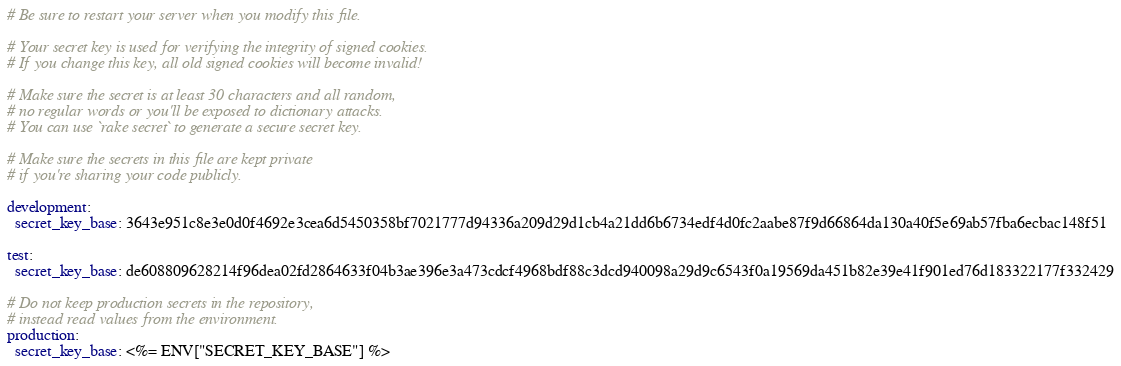Convert code to text. <code><loc_0><loc_0><loc_500><loc_500><_YAML_># Be sure to restart your server when you modify this file.

# Your secret key is used for verifying the integrity of signed cookies.
# If you change this key, all old signed cookies will become invalid!

# Make sure the secret is at least 30 characters and all random,
# no regular words or you'll be exposed to dictionary attacks.
# You can use `rake secret` to generate a secure secret key.

# Make sure the secrets in this file are kept private
# if you're sharing your code publicly.

development:
  secret_key_base: 3643e951c8e3e0d0f4692e3cea6d5450358bf7021777d94336a209d29d1cb4a21dd6b6734edf4d0fc2aabe87f9d66864da130a40f5e69ab57fba6ecbac148f51

test:
  secret_key_base: de608809628214f96dea02fd2864633f04b3ae396e3a473cdcf4968bdf88c3dcd940098a29d9c6543f0a19569da451b82e39e41f901ed76d183322177f332429

# Do not keep production secrets in the repository,
# instead read values from the environment.
production:
  secret_key_base: <%= ENV["SECRET_KEY_BASE"] %>
</code> 